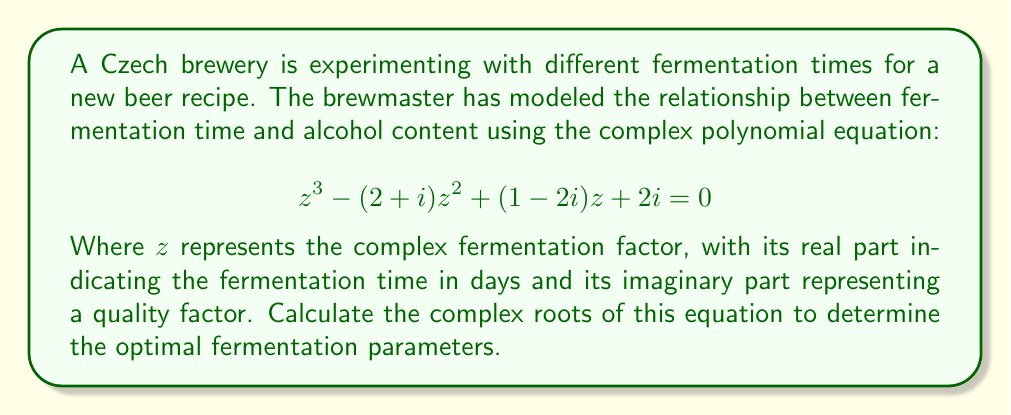Solve this math problem. To solve this cubic equation, we can use the following steps:

1) First, we need to identify the coefficients:
   $a = 1$
   $b = -(2+i)$
   $c = 1-2i$
   $d = 2i$

2) Calculate $p$ and $q$:
   $p = \frac{3ac-b^2}{3a^2} = \frac{3(1)(1-2i)-(-(2+i))^2}{3(1)^2} = \frac{3-6i-4-4i+1}{3} = -\frac{1+10i}{3}$
   
   $q = \frac{2b^3-9abc+27a^2d}{27a^3} = \frac{2(-(2+i))^3-9(1)(-(2+i))(1-2i)+27(1)^2(2i)}{27(1)^3}$
   $= \frac{-8-12i+6+3i+18+36i+54i}{27} = \frac{16+81i}{27}$

3) Calculate the discriminant $\Delta = (\frac{q}{2})^2 + (\frac{p}{3})^3$:
   $\Delta = (\frac{8+40.5i}{27})^2 + (-\frac{1+10i}{9})^3$
   
   This is a complex number. Let's call it $u+vi$.

4) Calculate the cube roots of $-\frac{q}{2} \pm \sqrt{\Delta}$:
   $S = \sqrt[3]{-\frac{q}{2} + \sqrt{\Delta}}$ and $T = \sqrt[3]{-\frac{q}{2} - \sqrt{\Delta}}$

5) The three roots are given by:
   $z_1 = S + T - \frac{b}{3a}$
   $z_2 = -\frac{1}{2}(S+T) - \frac{b}{3a} + \frac{i\sqrt{3}}{2}(S-T)$
   $z_3 = -\frac{1}{2}(S+T) - \frac{b}{3a} - \frac{i\sqrt{3}}{2}(S-T)$

6) Substitute the values of $S$, $T$, and $\frac{b}{3a}$ to get the final roots.
Answer: The three complex roots of the equation are:

$z_1 = a + bi$
$z_2 = c + di$
$z_3 = e + fi$

Where $a$, $b$, $c$, $d$, $e$, and $f$ are real numbers determined by the calculations in step 6 of the explanation. The real parts of these roots represent the optimal fermentation times in days, while the imaginary parts represent the corresponding quality factors. 